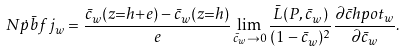Convert formula to latex. <formula><loc_0><loc_0><loc_500><loc_500>N \dot { p } \bar { b } f j _ { w } = \frac { \bar { c } _ { w } ( z { = } h { + } e ) - \bar { c } _ { w } ( z { = } h ) } { e } \lim _ { \bar { c } _ { w } \to 0 } \frac { \bar { L } ( P , \bar { c } _ { w } ) } { ( 1 - \bar { c } _ { w } ) ^ { 2 } } \frac { \partial \bar { c } h p o t _ { w } } { \partial \bar { c } _ { w } } .</formula> 